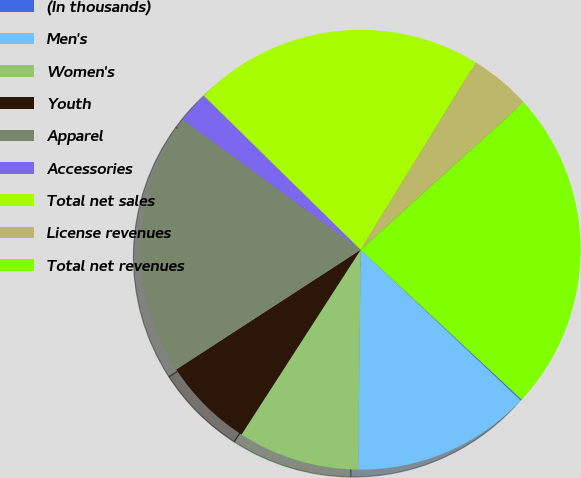Convert chart to OTSL. <chart><loc_0><loc_0><loc_500><loc_500><pie_chart><fcel>(In thousands)<fcel>Men's<fcel>Women's<fcel>Youth<fcel>Apparel<fcel>Accessories<fcel>Total net sales<fcel>License revenues<fcel>Total net revenues<nl><fcel>0.1%<fcel>13.16%<fcel>8.93%<fcel>6.72%<fcel>19.21%<fcel>2.31%<fcel>21.42%<fcel>4.52%<fcel>23.63%<nl></chart> 